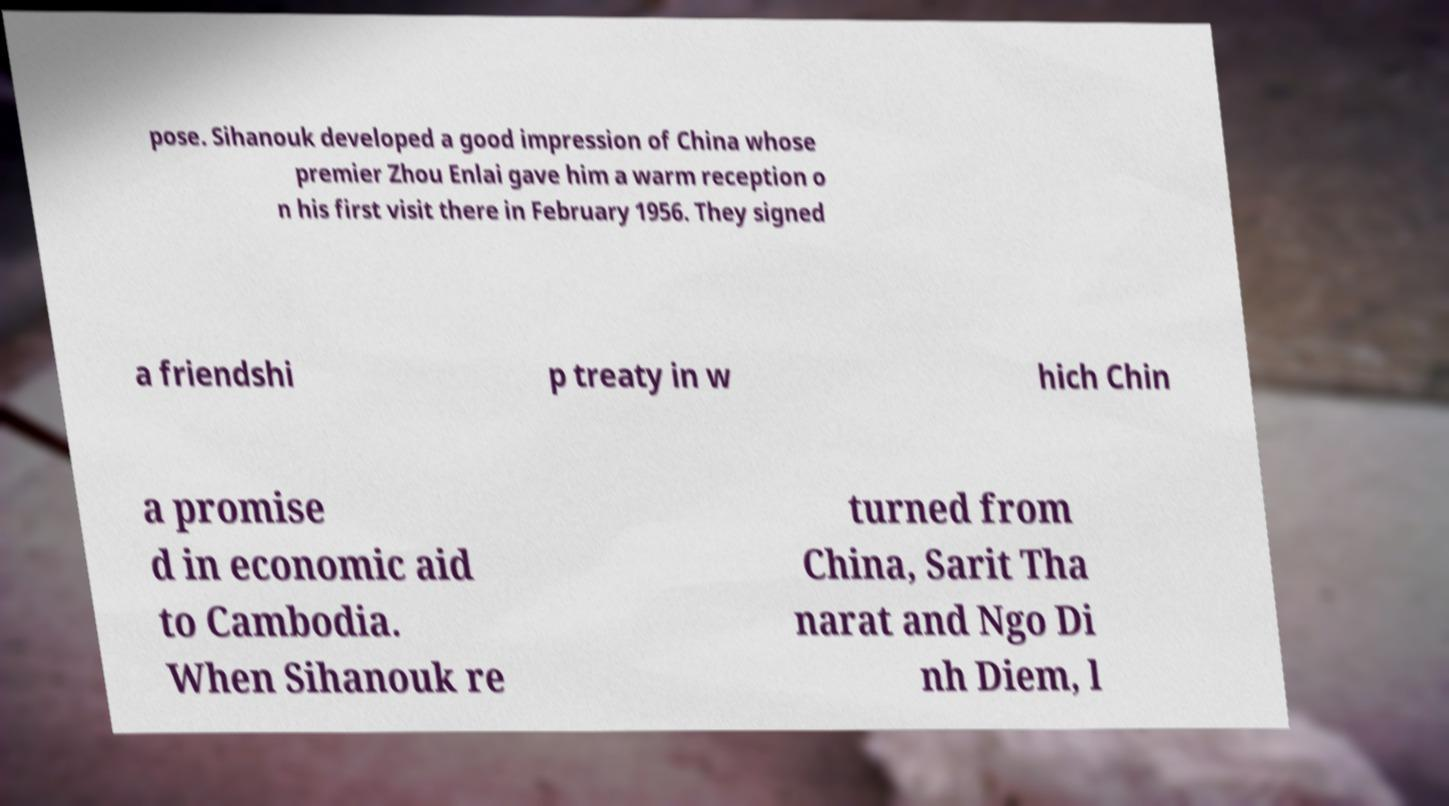Could you assist in decoding the text presented in this image and type it out clearly? pose. Sihanouk developed a good impression of China whose premier Zhou Enlai gave him a warm reception o n his first visit there in February 1956. They signed a friendshi p treaty in w hich Chin a promise d in economic aid to Cambodia. When Sihanouk re turned from China, Sarit Tha narat and Ngo Di nh Diem, l 